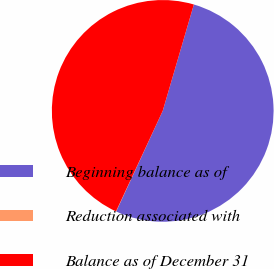Convert chart. <chart><loc_0><loc_0><loc_500><loc_500><pie_chart><fcel>Beginning balance as of<fcel>Reduction associated with<fcel>Balance as of December 31<nl><fcel>52.36%<fcel>0.03%<fcel>47.6%<nl></chart> 